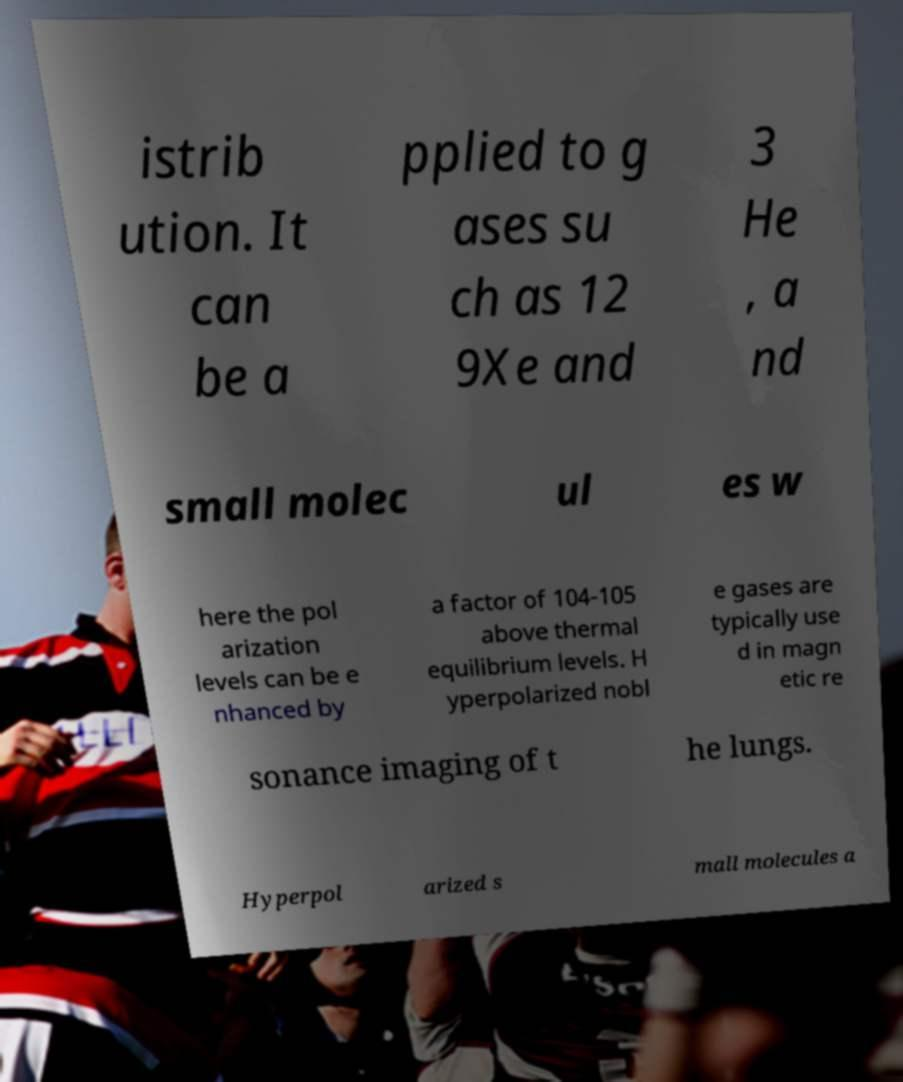For documentation purposes, I need the text within this image transcribed. Could you provide that? istrib ution. It can be a pplied to g ases su ch as 12 9Xe and 3 He , a nd small molec ul es w here the pol arization levels can be e nhanced by a factor of 104-105 above thermal equilibrium levels. H yperpolarized nobl e gases are typically use d in magn etic re sonance imaging of t he lungs. Hyperpol arized s mall molecules a 